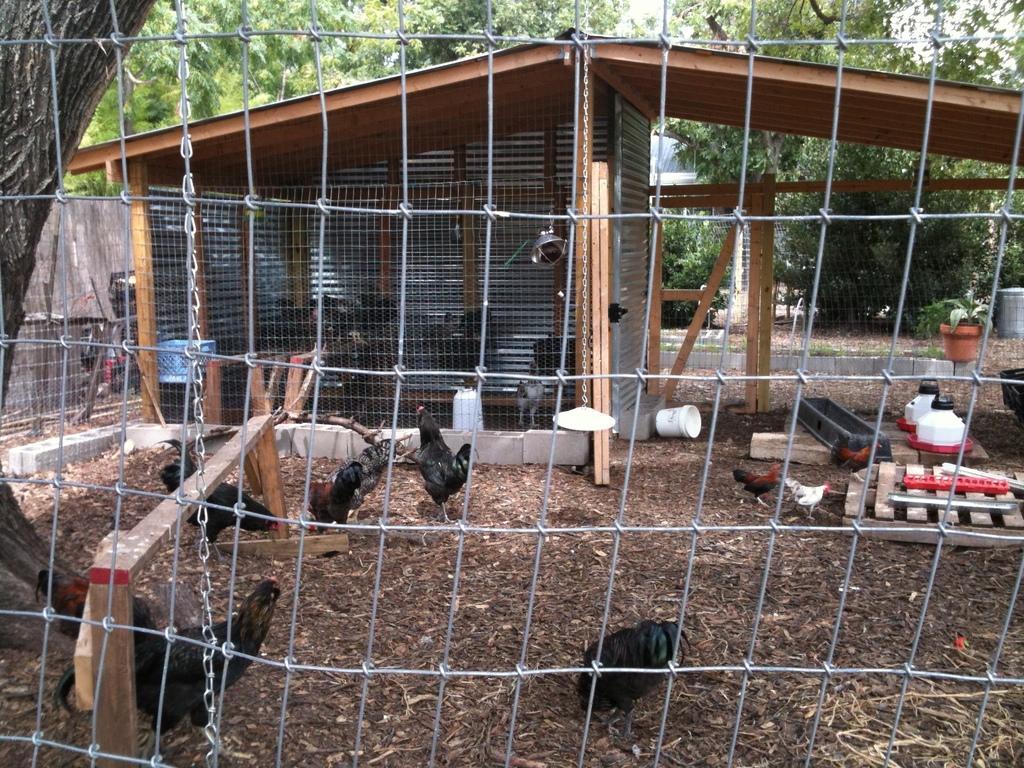Can you describe this image briefly? In this image we can see some hens, fencing, shed, chain, plate, there are trees, plants, wooden poles, cans, also we can see the wall. 